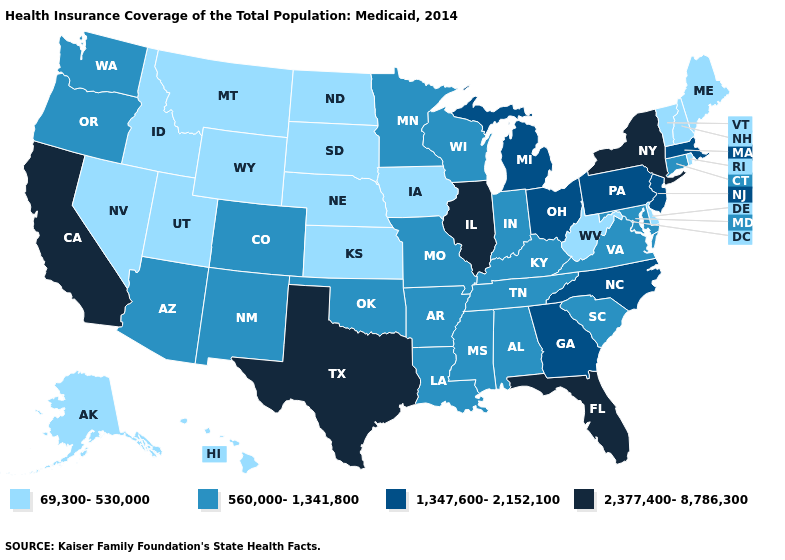Does Pennsylvania have the same value as Arkansas?
Keep it brief. No. What is the lowest value in states that border Montana?
Short answer required. 69,300-530,000. What is the value of North Dakota?
Keep it brief. 69,300-530,000. Name the states that have a value in the range 69,300-530,000?
Write a very short answer. Alaska, Delaware, Hawaii, Idaho, Iowa, Kansas, Maine, Montana, Nebraska, Nevada, New Hampshire, North Dakota, Rhode Island, South Dakota, Utah, Vermont, West Virginia, Wyoming. Does New York have the highest value in the USA?
Quick response, please. Yes. Name the states that have a value in the range 1,347,600-2,152,100?
Keep it brief. Georgia, Massachusetts, Michigan, New Jersey, North Carolina, Ohio, Pennsylvania. Name the states that have a value in the range 2,377,400-8,786,300?
Keep it brief. California, Florida, Illinois, New York, Texas. Which states have the lowest value in the USA?
Be succinct. Alaska, Delaware, Hawaii, Idaho, Iowa, Kansas, Maine, Montana, Nebraska, Nevada, New Hampshire, North Dakota, Rhode Island, South Dakota, Utah, Vermont, West Virginia, Wyoming. Which states have the highest value in the USA?
Write a very short answer. California, Florida, Illinois, New York, Texas. Name the states that have a value in the range 560,000-1,341,800?
Concise answer only. Alabama, Arizona, Arkansas, Colorado, Connecticut, Indiana, Kentucky, Louisiana, Maryland, Minnesota, Mississippi, Missouri, New Mexico, Oklahoma, Oregon, South Carolina, Tennessee, Virginia, Washington, Wisconsin. What is the lowest value in the USA?
Keep it brief. 69,300-530,000. Name the states that have a value in the range 69,300-530,000?
Write a very short answer. Alaska, Delaware, Hawaii, Idaho, Iowa, Kansas, Maine, Montana, Nebraska, Nevada, New Hampshire, North Dakota, Rhode Island, South Dakota, Utah, Vermont, West Virginia, Wyoming. What is the lowest value in the USA?
Short answer required. 69,300-530,000. Which states hav the highest value in the MidWest?
Answer briefly. Illinois. Does the first symbol in the legend represent the smallest category?
Write a very short answer. Yes. 